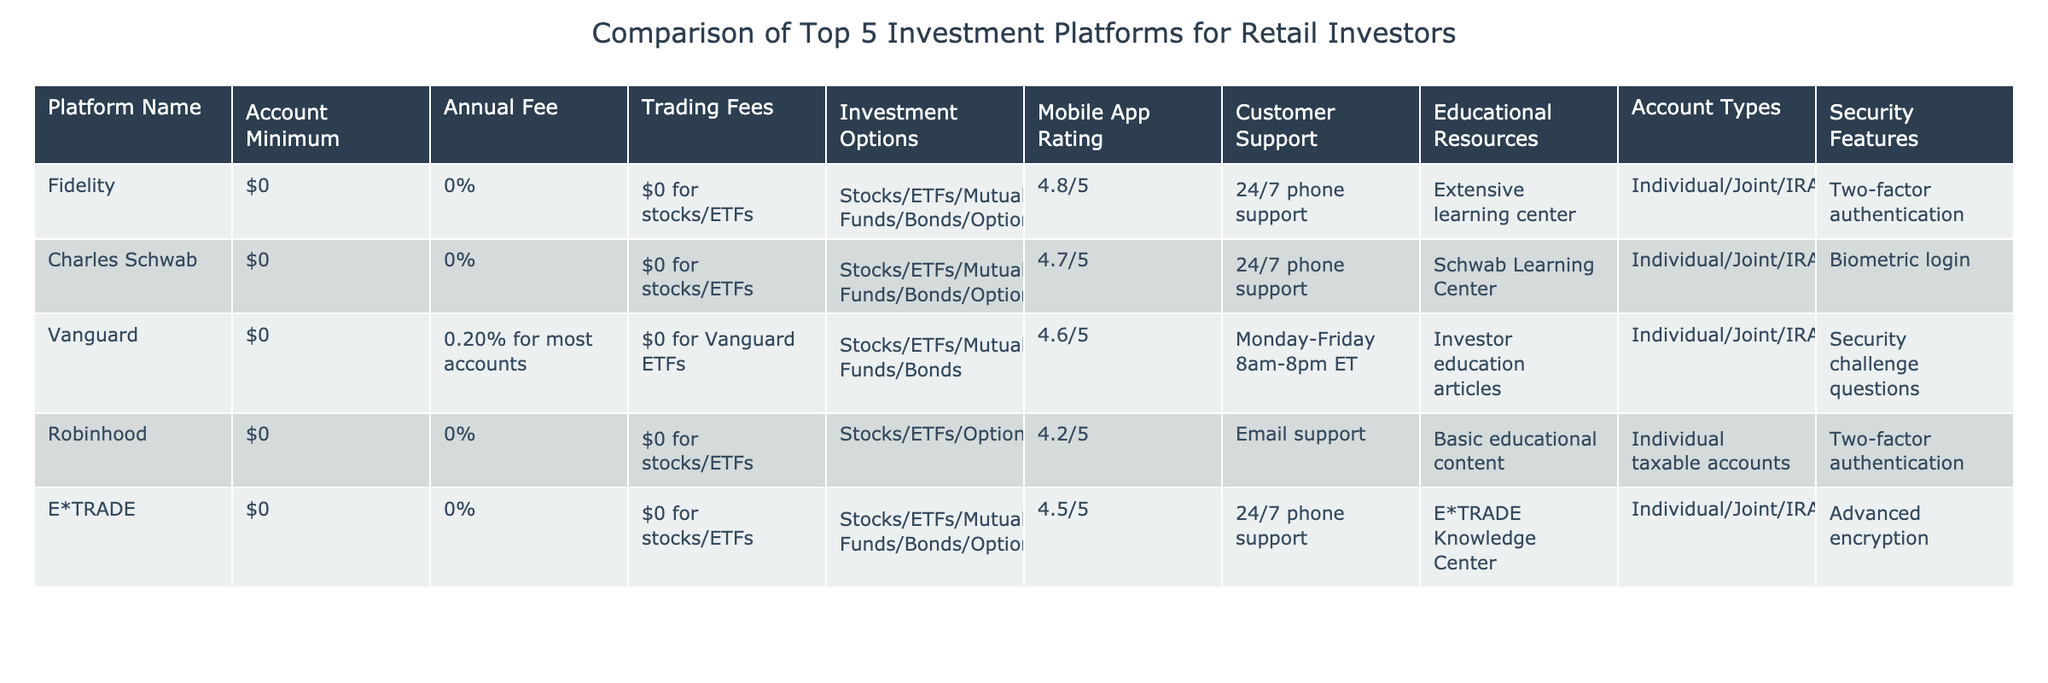What is the account minimum for Charles Schwab? The table indicates that Charles Schwab has an account minimum of $0.
Answer: $0 Which platform has the highest mobile app rating? By comparing the mobile app ratings in the table (Fidelity: 4.8, Charles Schwab: 4.7, Vanguard: 4.6, Robinhood: 4.2, E*TRADE: 4.5), Fidelity has the highest rating of 4.8.
Answer: Fidelity Is there an annual fee for Robinhood? The table shows that Robinhood has an annual fee of 0%, meaning there is no annual fee charged.
Answer: No What is the average trading fee across the platforms? All platforms listed charge $0 for trading fees on stocks and ETFs. Thus, the average trading fee is $0.
Answer: $0 Do all platforms provide 24/7 customer support? The table indicates that Fidelity, Charles Schwab, and E*TRADE offer 24/7 phone support, while Vanguard has limited hours (Monday-Friday 8am-8pm ET) and Robinhood offers email support. Therefore, not all platforms provide 24/7 customer support.
Answer: No Which platform offers the most investment options? The table shows that Fidelity, Charles Schwab, and E*TRADE offer Stocks/ETFs/Mutual Funds/Bonds/Options for investment options. Vanguard offers Stocks/ETFs/Mutual Funds/Bonds, while Robinhood offers Stocks/ETFs/Options/Cryptocurrencies. Therefore, Fidelity, Charles Schwab, and E*TRADE provide the most investment options.
Answer: Fidelity, Charles Schwab, E*TRADE How many platforms use two-factor authentication for security? The platforms that use two-factor authentication for security are Fidelity and Robinhood. Since there are 2 platforms using this feature, the answer is 2.
Answer: 2 Which platform has a higher annual fee: Vanguard or Robinhood? Vanguard has an annual fee of 0.20%, while Robinhood has an annual fee of 0%. Therefore, Vanguard has a higher annual fee.
Answer: Vanguard What type of account can you open with Charles Schwab? The table lists that Charles Schwab offers various account types, including Individual, Joint, IRA, and 401(k).
Answer: Individual/Joint/IRA/401(k) 